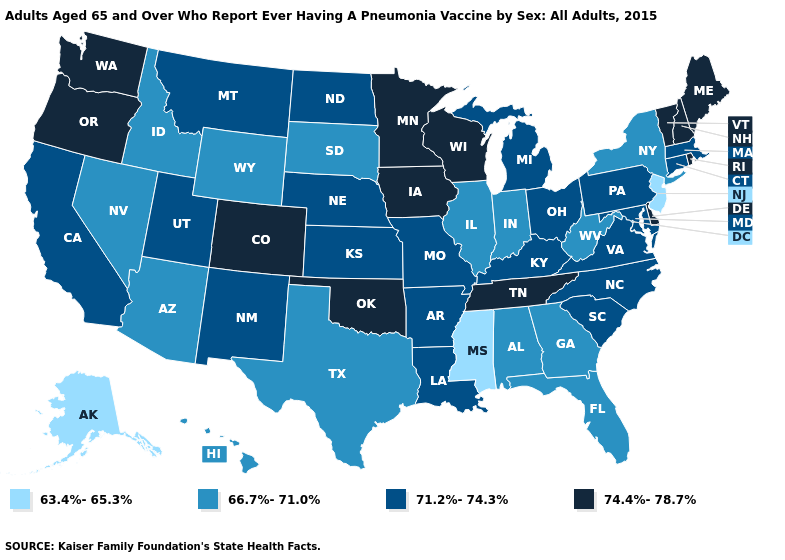Does the first symbol in the legend represent the smallest category?
Write a very short answer. Yes. What is the highest value in the MidWest ?
Quick response, please. 74.4%-78.7%. Is the legend a continuous bar?
Write a very short answer. No. Does Ohio have the highest value in the MidWest?
Be succinct. No. Name the states that have a value in the range 71.2%-74.3%?
Answer briefly. Arkansas, California, Connecticut, Kansas, Kentucky, Louisiana, Maryland, Massachusetts, Michigan, Missouri, Montana, Nebraska, New Mexico, North Carolina, North Dakota, Ohio, Pennsylvania, South Carolina, Utah, Virginia. What is the value of Iowa?
Keep it brief. 74.4%-78.7%. What is the lowest value in states that border Maryland?
Quick response, please. 66.7%-71.0%. What is the value of Georgia?
Write a very short answer. 66.7%-71.0%. Name the states that have a value in the range 71.2%-74.3%?
Concise answer only. Arkansas, California, Connecticut, Kansas, Kentucky, Louisiana, Maryland, Massachusetts, Michigan, Missouri, Montana, Nebraska, New Mexico, North Carolina, North Dakota, Ohio, Pennsylvania, South Carolina, Utah, Virginia. What is the value of North Carolina?
Concise answer only. 71.2%-74.3%. How many symbols are there in the legend?
Concise answer only. 4. Does Kansas have a lower value than South Dakota?
Keep it brief. No. Does Texas have the lowest value in the USA?
Quick response, please. No. What is the highest value in the USA?
Write a very short answer. 74.4%-78.7%. Does Maryland have a lower value than Idaho?
Quick response, please. No. 